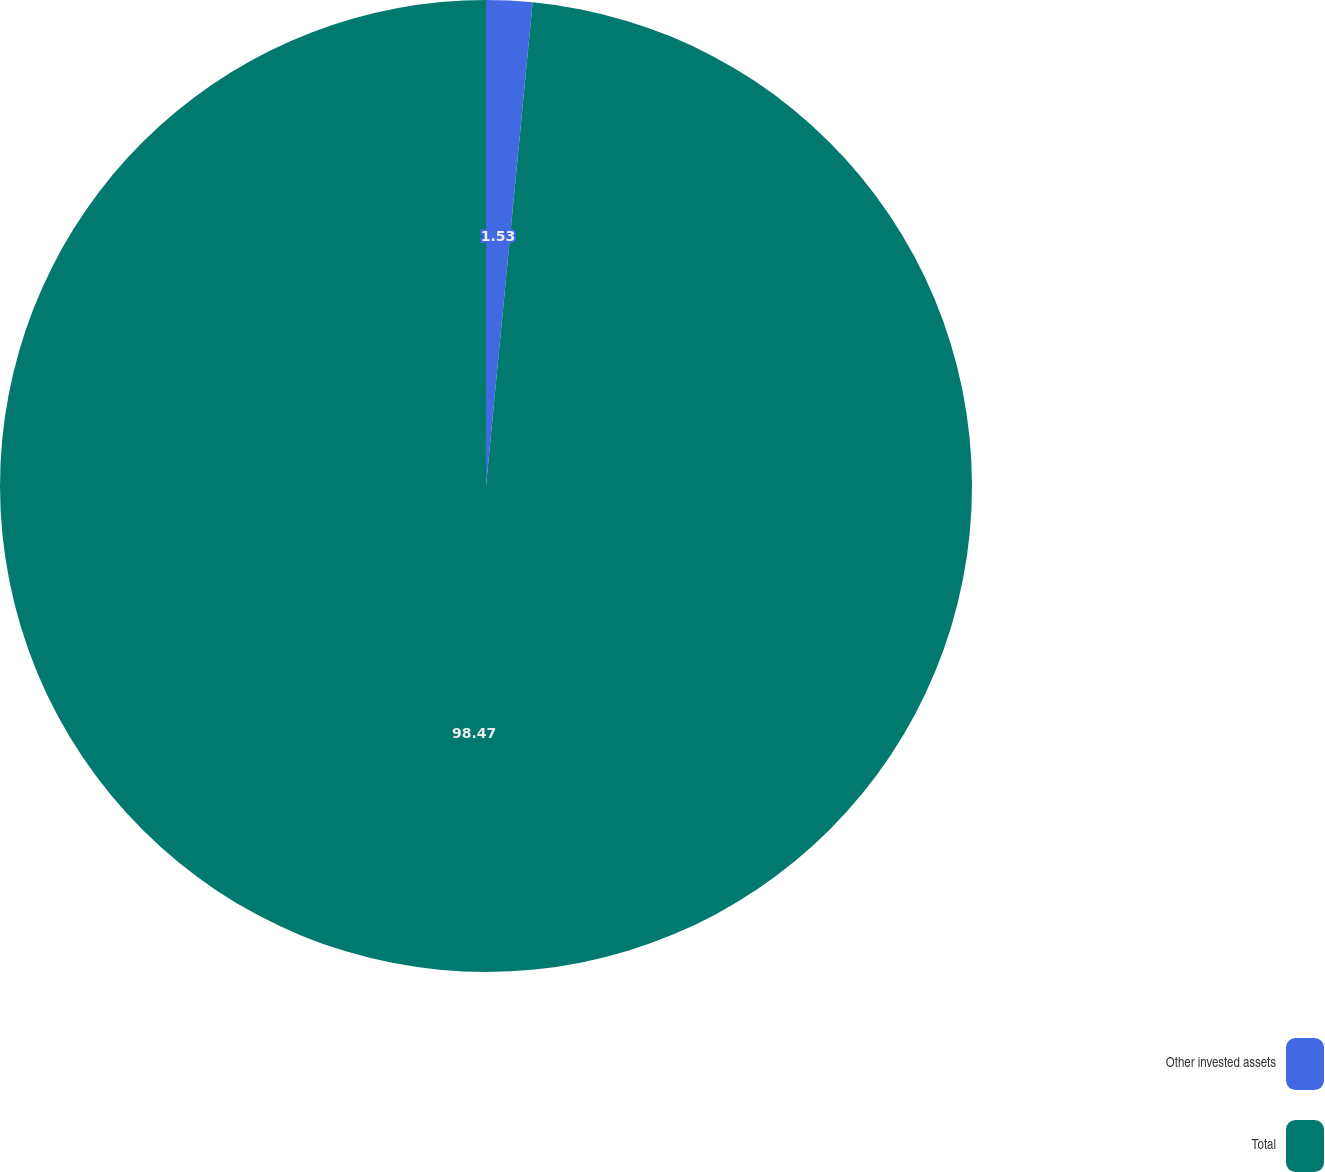<chart> <loc_0><loc_0><loc_500><loc_500><pie_chart><fcel>Other invested assets<fcel>Total<nl><fcel>1.53%<fcel>98.47%<nl></chart> 